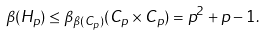Convert formula to latex. <formula><loc_0><loc_0><loc_500><loc_500>\beta ( H _ { p } ) \leq \beta _ { \beta ( C _ { p } ) } ( C _ { p } \times C _ { p } ) = p ^ { 2 } + p - 1 .</formula> 